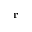Convert formula to latex. <formula><loc_0><loc_0><loc_500><loc_500>r</formula> 